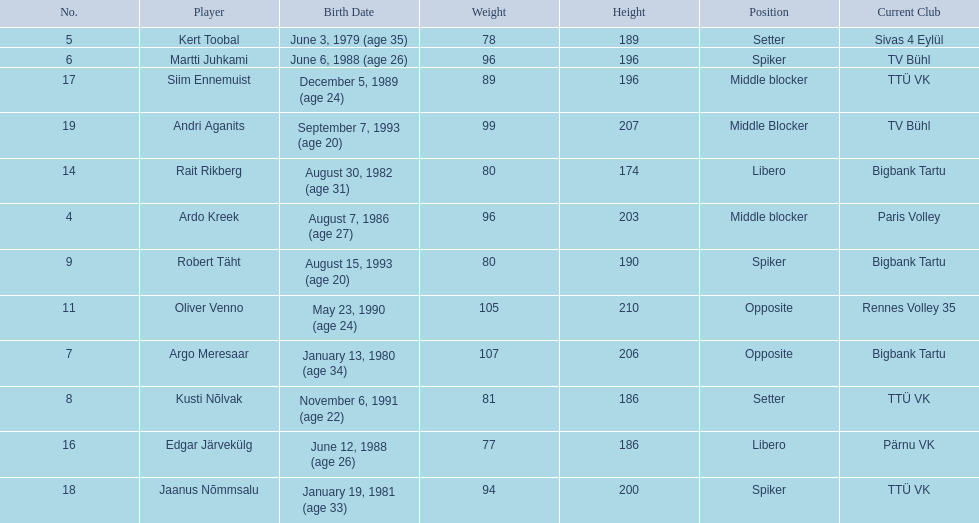How many players were born before 1988? 5. 